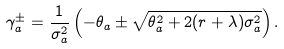<formula> <loc_0><loc_0><loc_500><loc_500>\gamma ^ { \pm } _ { a } = \frac { 1 } { \sigma ^ { 2 } _ { a } } \left ( - \theta _ { a } \pm \sqrt { \theta ^ { 2 } _ { a } + 2 ( r + \lambda ) \sigma ^ { 2 } _ { a } } \right ) .</formula> 